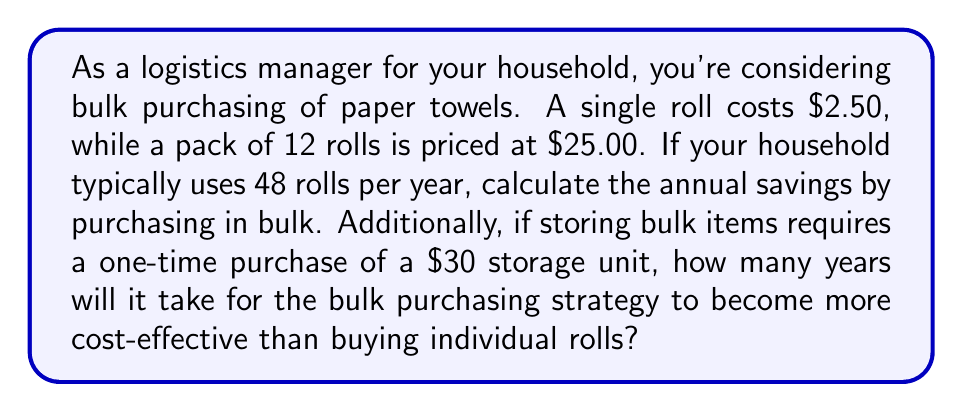Provide a solution to this math problem. Let's break this problem down into steps:

1. Calculate the cost of buying individual rolls for a year:
   $$ 48 \text{ rolls} \times \$2.50 \text{ per roll} = \$120 \text{ per year} $$

2. Calculate the cost of buying in bulk for a year:
   $$ 4 \text{ packs} \times \$25.00 \text{ per pack} = \$100 \text{ per year} $$

3. Calculate the annual savings:
   $$ \$120 - \$100 = \$20 \text{ per year} $$

4. To determine how long it will take for bulk purchasing to become more cost-effective, we need to consider the additional storage unit cost:
   
   Let $x$ be the number of years. We want to find when the total cost of bulk purchasing equals the cost of individual purchases:

   $$ 100x + 30 = 120x $$

   Solving for $x$:
   $$ 30 = 20x $$
   $$ x = \frac{30}{20} = 1.5 \text{ years} $$

Therefore, it will take 1.5 years for the bulk purchasing strategy to become more cost-effective than buying individual rolls, considering the storage unit cost.
Answer: Annual savings from bulk purchasing: $20
Time for bulk purchasing to become more cost-effective: 1.5 years 